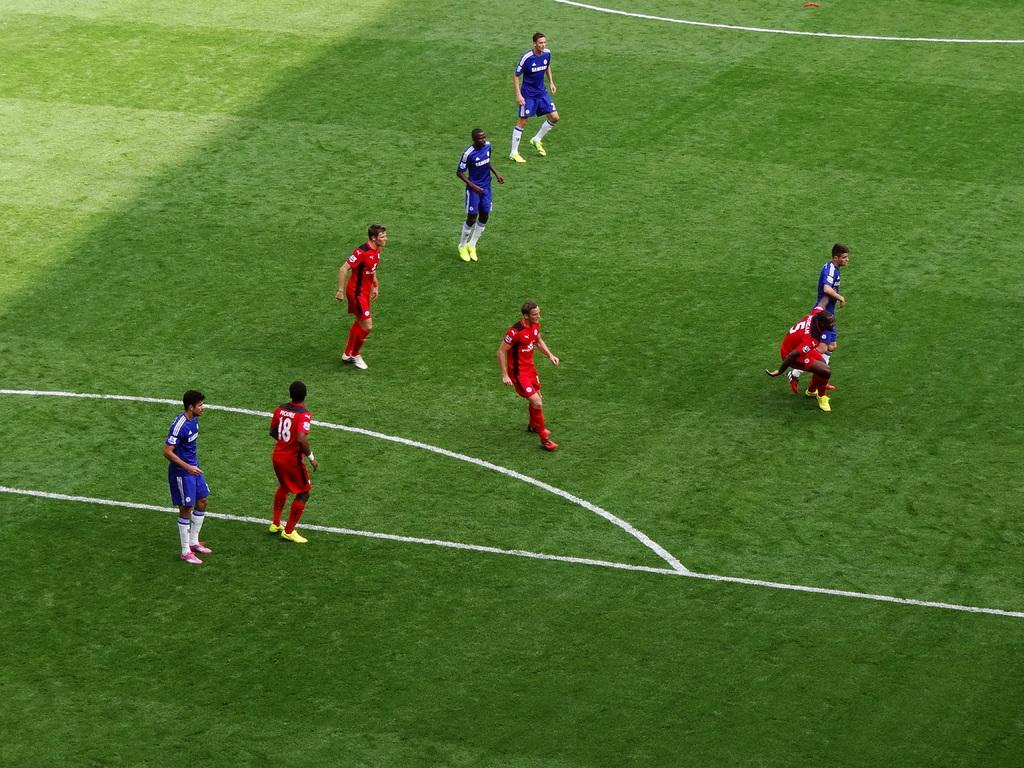Provide a one-sentence caption for the provided image. A player wearing red with number 5 on the back falls to the ground. 